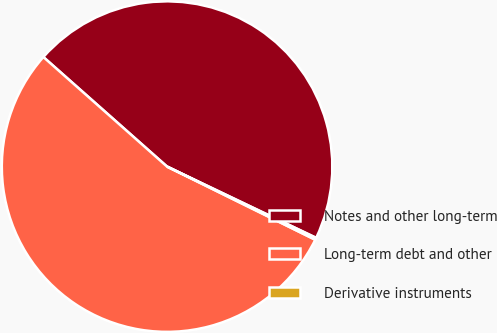<chart> <loc_0><loc_0><loc_500><loc_500><pie_chart><fcel>Notes and other long-term<fcel>Long-term debt and other<fcel>Derivative instruments<nl><fcel>45.56%<fcel>54.24%<fcel>0.2%<nl></chart> 